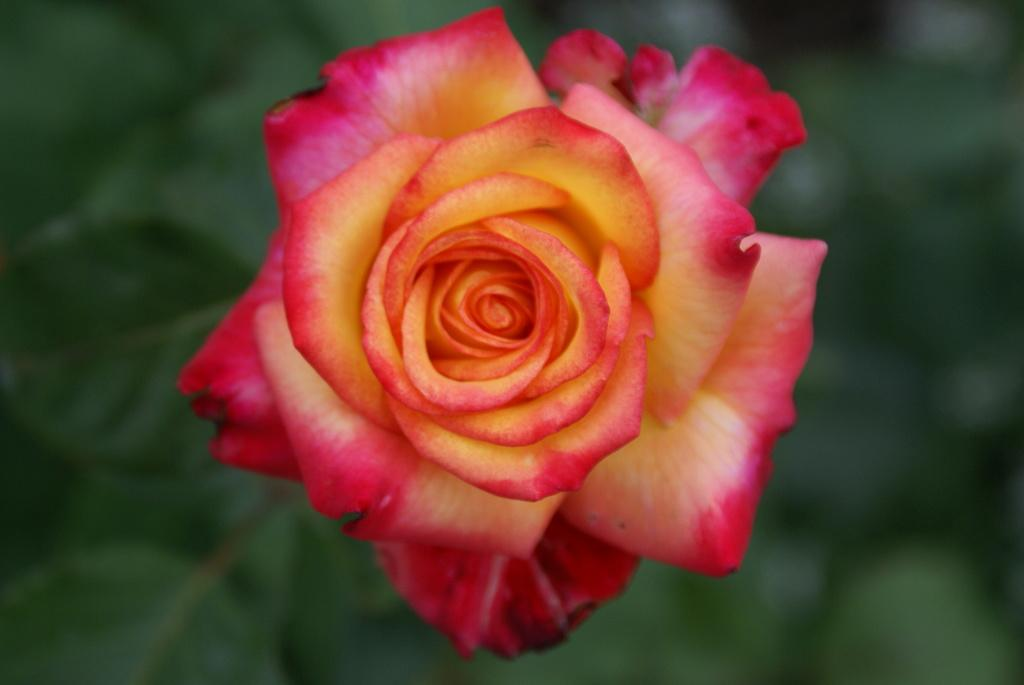What is the main subject of the image? There is a flower in the image. Can you describe the colors of the flower? The flower has yellow and red colors. What else can be seen in the background of the image? There is a plant in the background of the image. What is the color of the plant? The plant is green in color. Are there any fairies flying around the flower in the image? There is no indication of fairies in the image; it only features a flower and a plant in the background. Can you see a goat grazing on the plant in the background? There is no goat present in the image; it only features a flower and a plant in the background. 